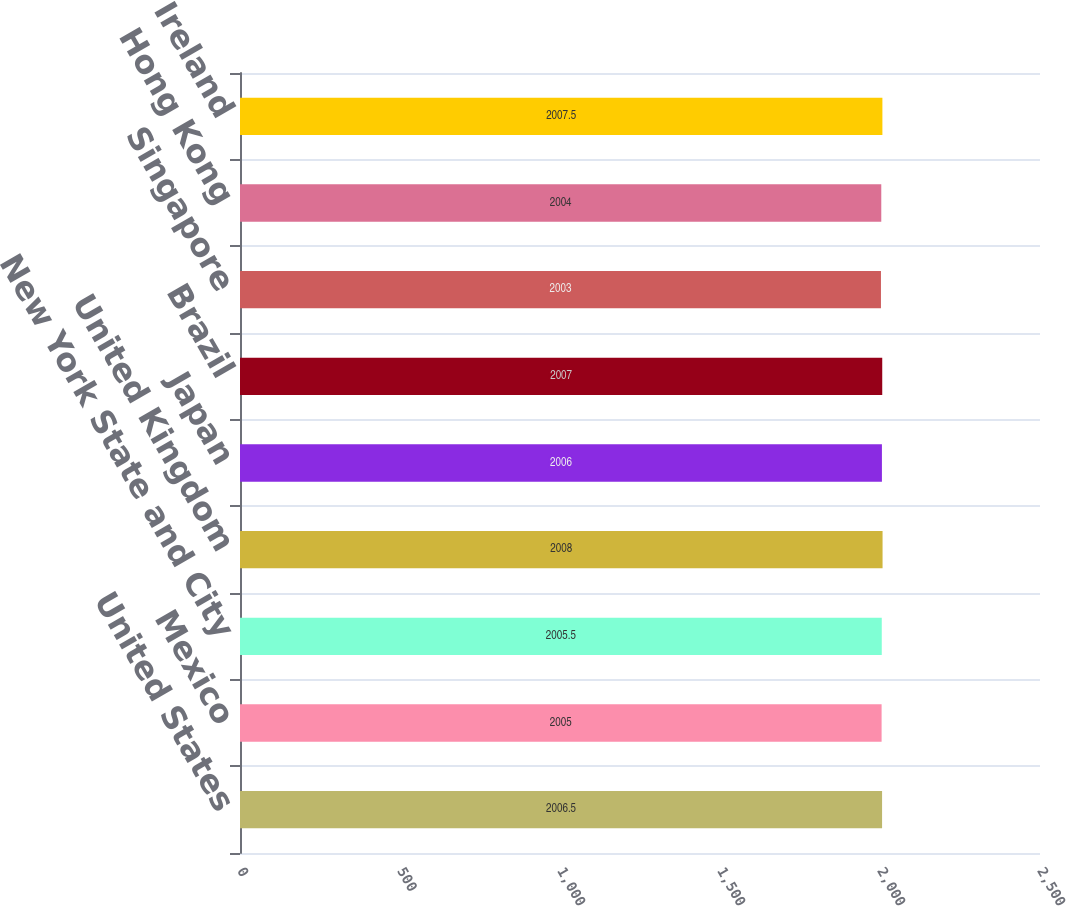<chart> <loc_0><loc_0><loc_500><loc_500><bar_chart><fcel>United States<fcel>Mexico<fcel>New York State and City<fcel>United Kingdom<fcel>Japan<fcel>Brazil<fcel>Singapore<fcel>Hong Kong<fcel>Ireland<nl><fcel>2006.5<fcel>2005<fcel>2005.5<fcel>2008<fcel>2006<fcel>2007<fcel>2003<fcel>2004<fcel>2007.5<nl></chart> 